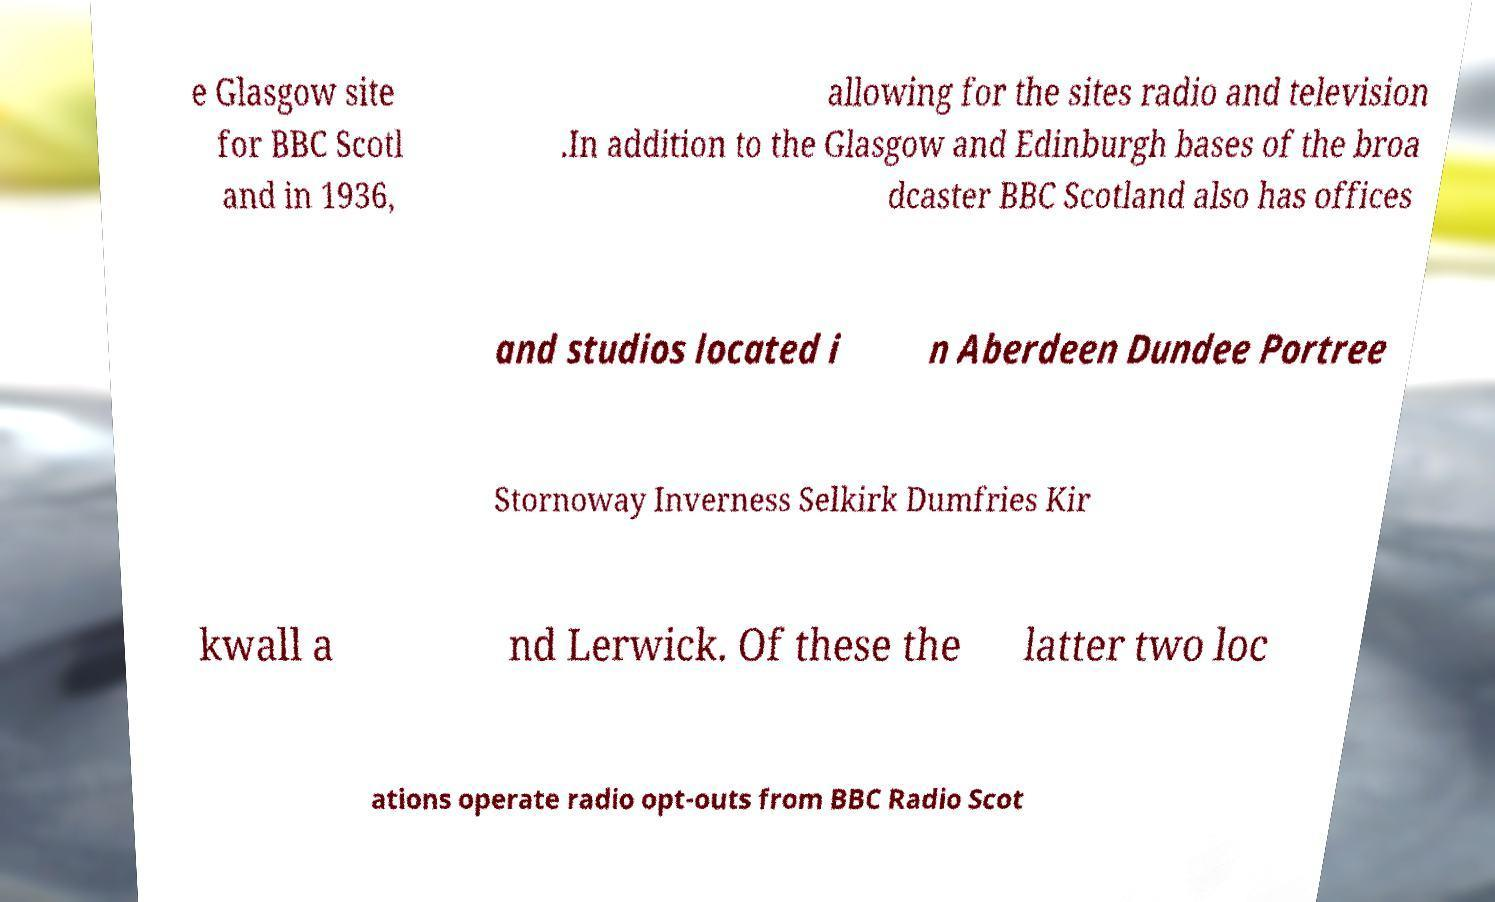Could you assist in decoding the text presented in this image and type it out clearly? e Glasgow site for BBC Scotl and in 1936, allowing for the sites radio and television .In addition to the Glasgow and Edinburgh bases of the broa dcaster BBC Scotland also has offices and studios located i n Aberdeen Dundee Portree Stornoway Inverness Selkirk Dumfries Kir kwall a nd Lerwick. Of these the latter two loc ations operate radio opt-outs from BBC Radio Scot 